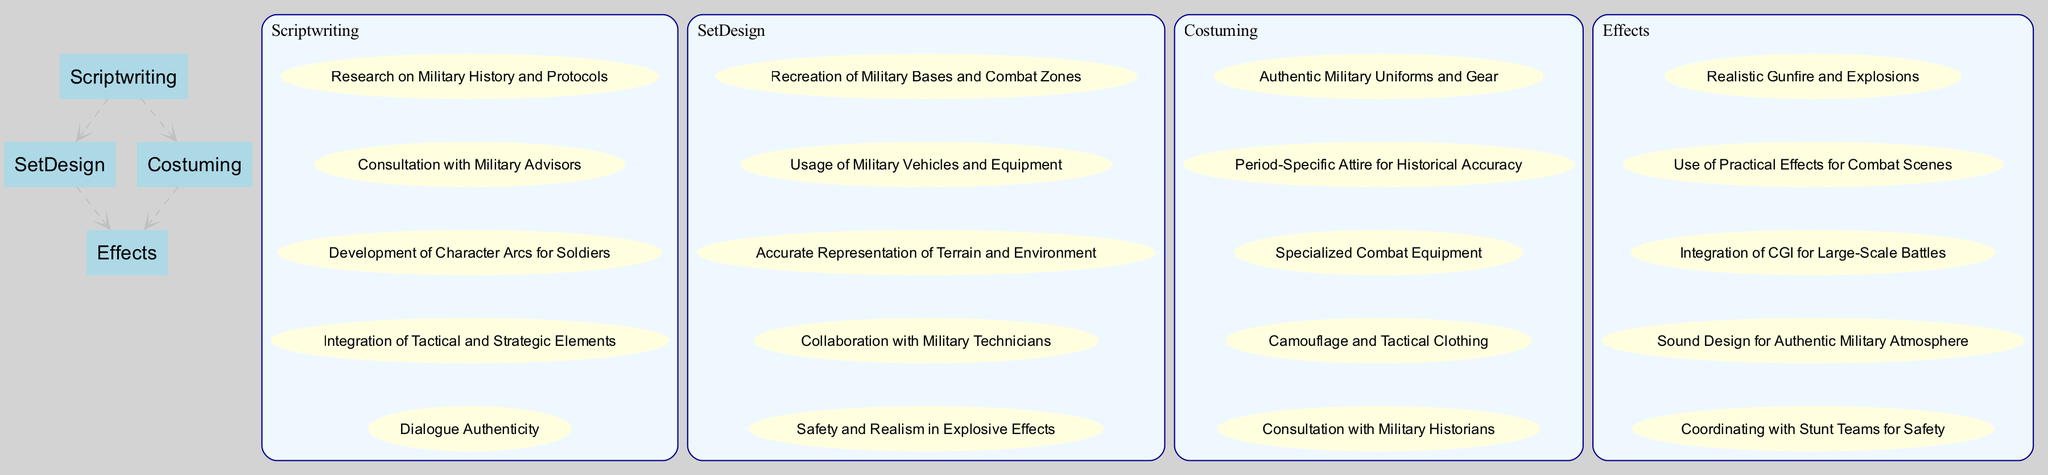What are the four key departments in a military-themed movie production? The diagram clearly lists the key departments as Scriptwriting, Set Design, Costuming, and Effects. These are the main nodes directly visible in the structure of the diagram.
Answer: Scriptwriting, Set Design, Costuming, Effects How many elements are listed under Costuming? In the subgraph for Costuming, there are five elements enumerated. Counting each one from the diagram confirms this number.
Answer: 5 Which department connects to Effects directly? The diagram shows direct connections (edges) leading to the Effects department from both Set Design and Costuming.
Answer: Set Design, Costuming What is the main purpose of Scriptwriting in the military-themed movie production? Reviewing the elements listed under Scriptwriting, its main purpose appears to focus on creating a realistic and engaging narrative around military themes, which includes aspects such as research and character development.
Answer: Creating realistic narratives What specific aspect does Set Design focus on for realism? The diagram indicates that Set Design emphasizes the recreation of authentic military environments, which includes accurate representation of military bases and combat zones as stated in its elements.
Answer: Recreation of military environments How many total edges connect the key departments? The diagram shows that there are four connections (edges) linking the departments together: from Scriptwriting to Set Design, from Scriptwriting to Costuming, from Set Design to Effects, and from Costuming to Effects, which totals to four edges.
Answer: 4 Which element under Effects involves cooperation with another team? The element under Effects that mentions cooperation with other personnel is "Coordinating with Stunt Teams for Safety," highlighting the importance of safety during filming.
Answer: Coordinating with Stunt Teams for Safety What detail is common across all four departments in terms of their focus? Each department focuses on achieving authenticity and realism within military themes, evident from their respective elements that strive for accuracy in various aspects like dialogue, costumes, and combat effects.
Answer: Authenticity and realism Which department is primarily responsible for the visual style and design of military uniforms? The Costuming department is specifically responsible for visual style and design of military uniforms, focusing on authenticity and historical accuracy as noted in its list of elements.
Answer: Costuming 